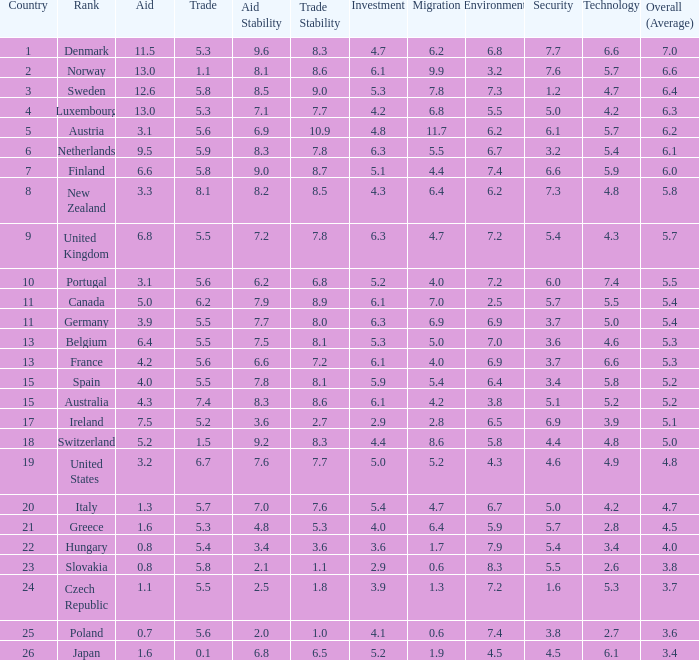How many times is denmark ranked in technology? 1.0. 